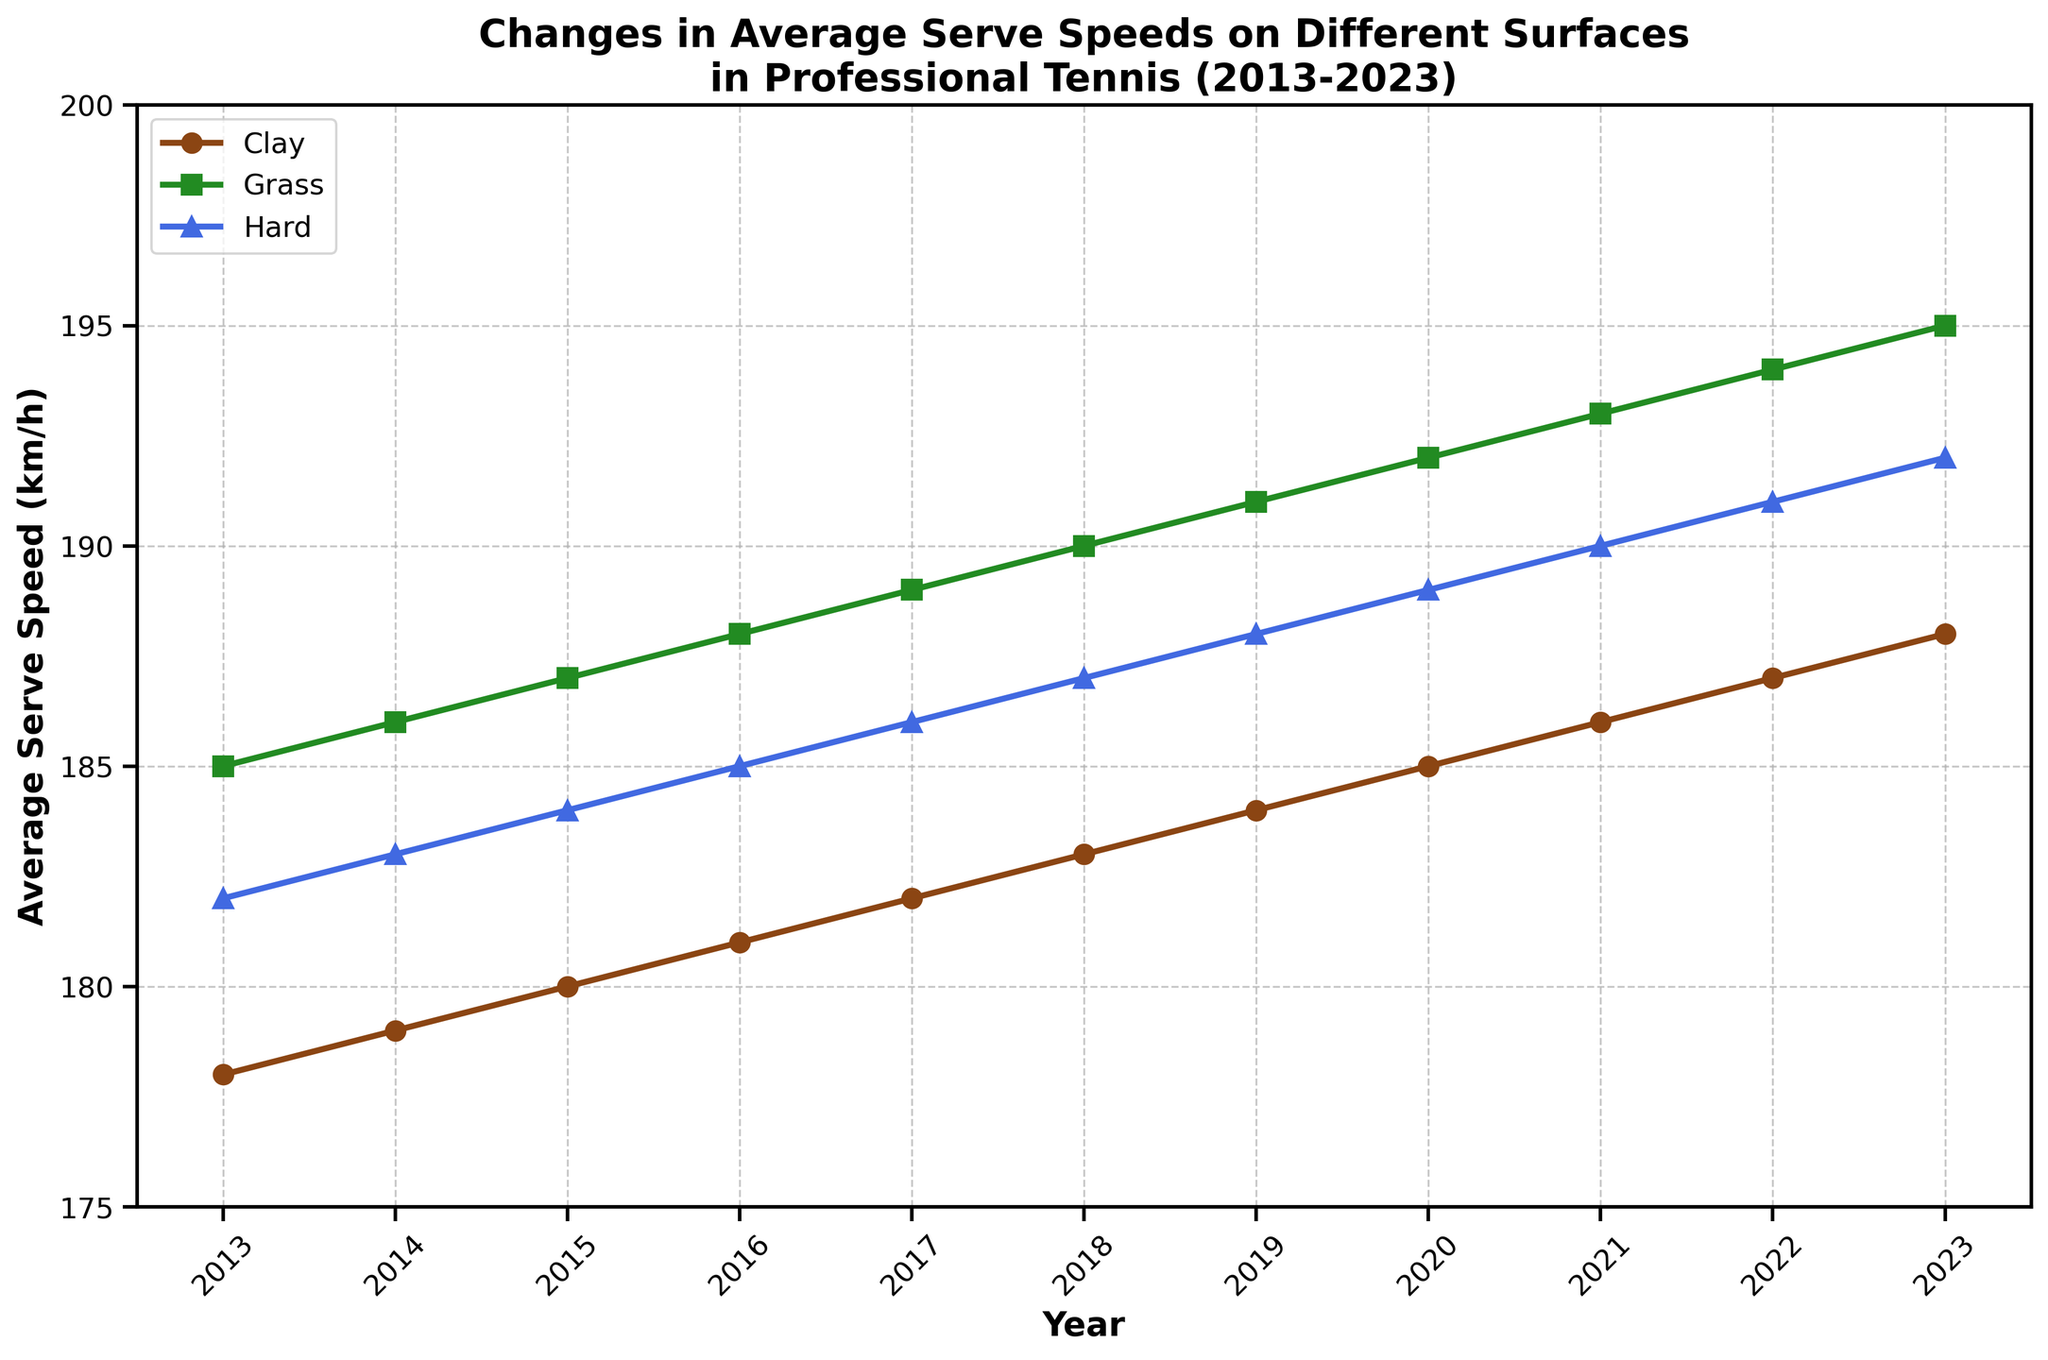What was the average serve speed increase on each surface from 2013 to 2023? Calculate the speed difference for each surface between 2023 and 2013: Clay (188 - 178 = 10 km/h), Grass (195 - 185 = 10 km/h), Hard Court (192 - 182 = 10 km/h).
Answer: 10 km/h for all surfaces Which year showed the highest average serve speed on grass? Check the values for Grass (km/h) from 2013 to 2023. The highest value is 195 km/h in 2023.
Answer: 2023 How did the average serve speed on hard court in 2020 compare to that on clay in the same year? For 2020, the average serve speed on Hard Court is 189 km/h, and on Clay is 185 km/h. Compare these two values.
Answer: 4 km/h higher on Hard Court What is the difference in average speed between serving on grass and clay in 2023? For 2023, the serve speeds are Grass (195 km/h) and Clay (188 km/h). Find the difference: 195 - 188 = 7 km/h.
Answer: 7 km/h What is the visual pattern of the average serve speeds on all surfaces from 2013 to 2023? All surfaces show a steady increase in average serve speeds, indicated by the rising lines from 2013 to 2023.
Answer: Steady increase Between which consecutive years did the average serve speed on clay see the greatest increase? Calculate the yearly differences for Clay: 1 km/h between each year. Answer based on this information.
Answer: No difference, 1 km/h each year Compare the trends of average serve speeds on grass and hard court over the decade. Both Grass and Hard Court show consistent, parallel upward trends with Grass always being slightly higher than Hard Court each year.
Answer: Consistent upward trend, Grass higher What was the combined average serve speed for all surfaces in 2018? Add the speeds for all surfaces in 2018: Clay (183 km/h), Grass (190 km/h), Hard Court (187 km/h). Calculate the average: (183 + 190 + 187) / 3 = 186.67 km/h.
Answer: 186.67 km/h How did the serve speed on clay change in the first five years (2013-2018) compared to the last five years (2018-2023)? Calculate average speed change for first five years: (183 - 178) = 5 km/h. For last five years: (188 - 183) = 5 km/h.
Answer: Same change, 5 km/h What is the relationship between the lines representing serve speeds on different surfaces? Lines maintain consistent relative positions: Grass on top, Hard Court in the middle, Clay at the bottom, indicating higher serve speeds for Grass.
Answer: Consistent relative positions 